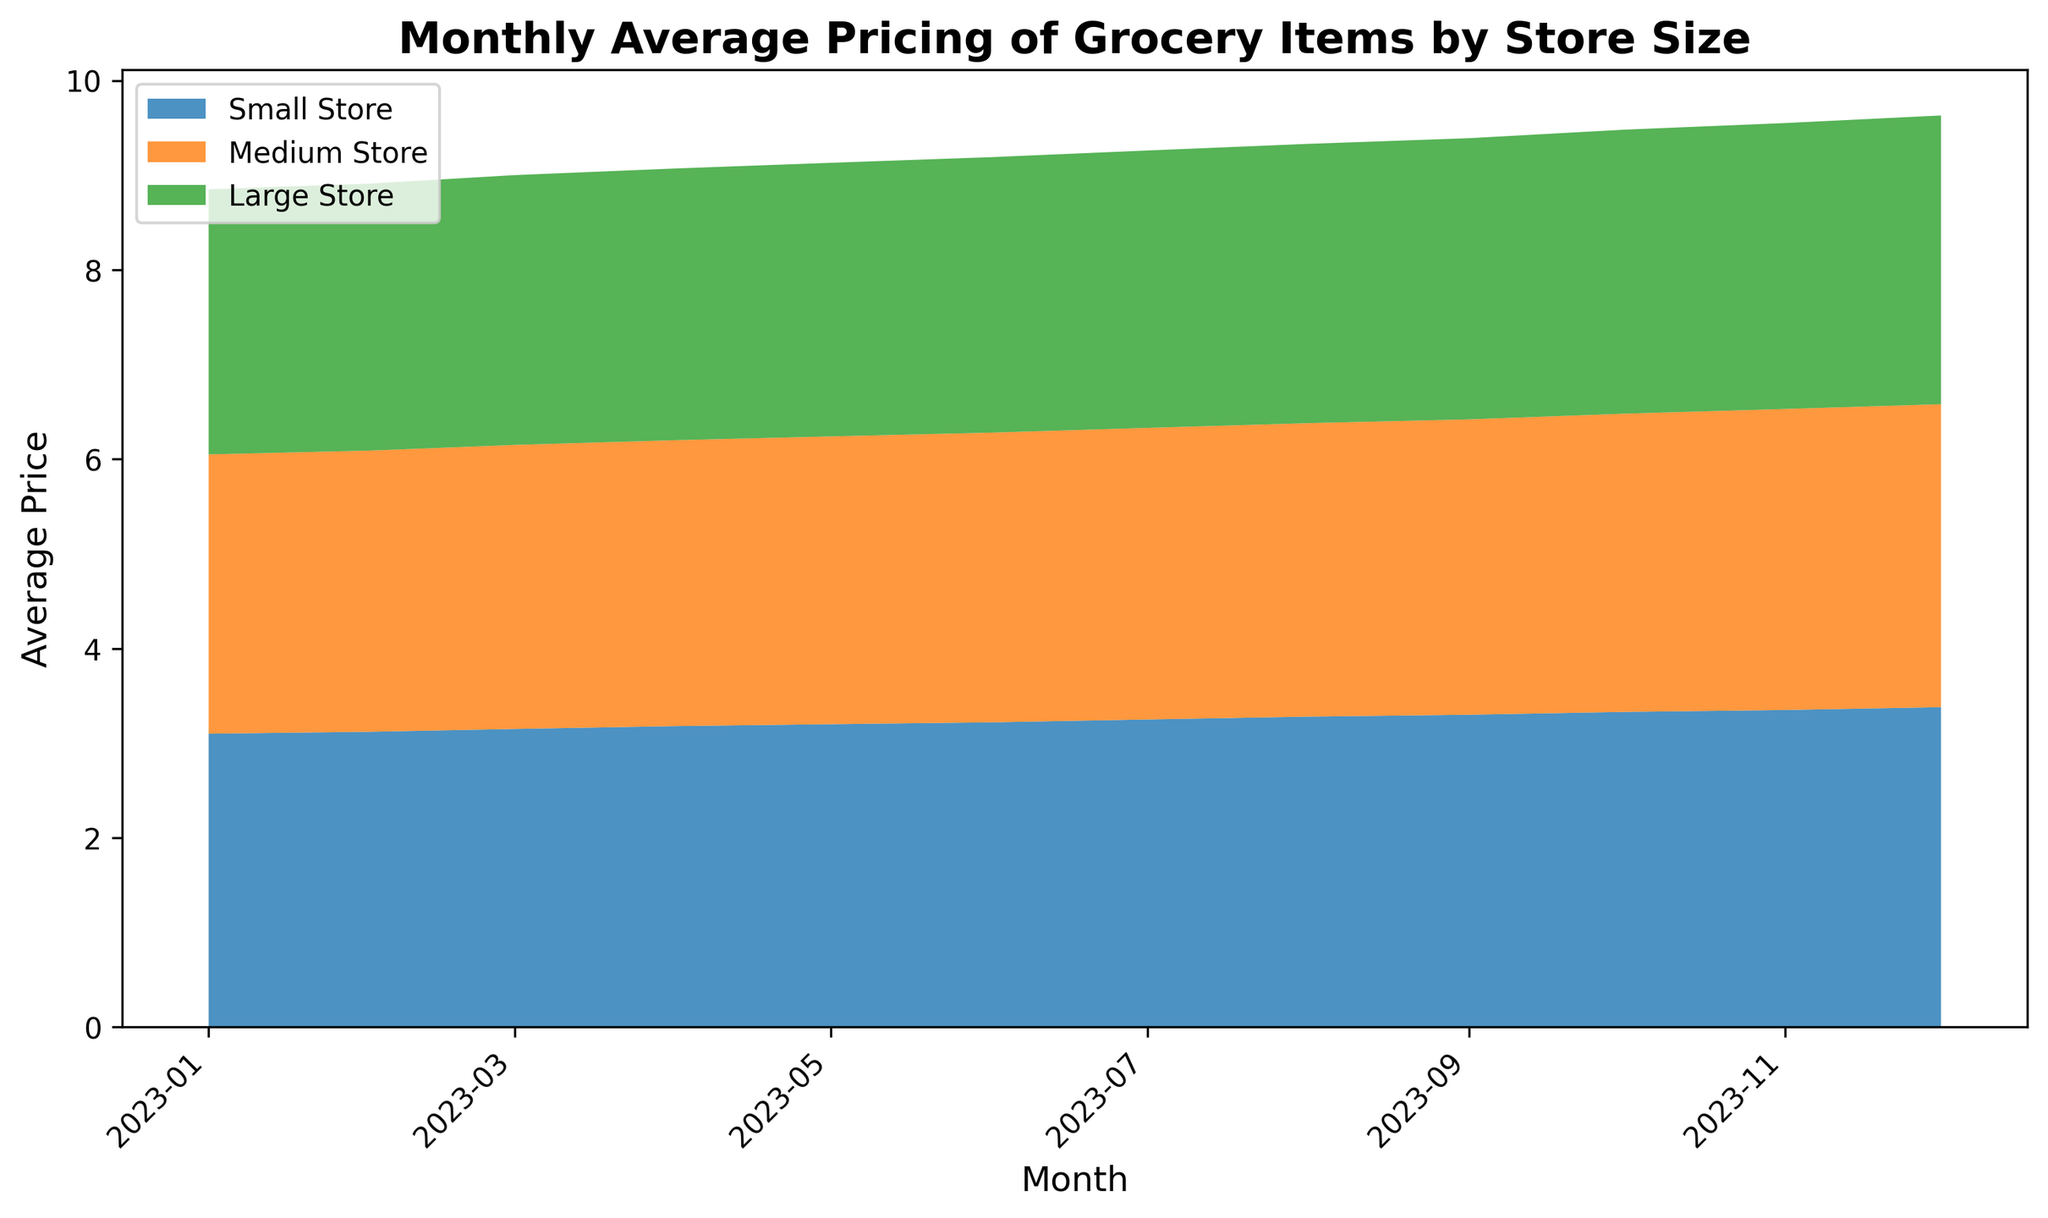what is the Monthly average pricing trend for small stores in 2023? The average prices in small stores started at $3.10 in January 2023 and increased consistently each month, ending at $3.38 in December 2023.
Answer: Increasing trend Which store size had the lowest average price in December 2023? In December 2023, the average price for small stores was $3.38, medium stores was $3.20, and large stores was $3.05. The lowest price was observed at large stores.
Answer: Large stores How does the average price in medium stores in April 2023 compare to that in June 2023? The average price in medium stores in April 2023 was $3.02, and in June 2023 it was $3.06. Thus, the price in June 2023 is higher than in April 2023.
Answer: Higher in June What is the difference in average price between small and large stores in October 2023? The average price in October 2023 for small stores was $3.33, and for large stores was $3.00. The difference is $3.33 - $3.00 = $0.33.
Answer: $0.33 Which store size shows the most significant price increase from January to December 2023? The average price in small stores increased from $3.10 in January to $3.38 in December, a change of $0.28. In medium stores, it increased from $2.95 to $3.20, a change of $0.25. For large stores, it went from $2.80 to $3.05, a change of $0.25. Thus, the small store shows the most significant increase.
Answer: Small stores What pattern can be observed in the prices of medium stores from March 2023 to July 2023? The average price in medium stores consistently increased from $3.00 in March 2023 to $3.08 in July 2023, indicating a steady growth pattern.
Answer: Consistent increase At which month do the prices of all store sizes converge closely together? The prices of all store sizes are closest in October 2023, where small stores are at $3.33, medium stores at $3.15, and large stores at $3.00.
Answer: October 2023 How much did the prices of large stores change from July to December 2023? The average price for large stores was $2.93 in July 2023 and $3.05 in December 2023. The change is $3.05 - $2.93 = $0.12.
Answer: $0.12 What is the average price in medium stores throughout 2023? Summing the monthly averages for medium stores: 2.95 + 2.97 + 3.00 + 3.02 + 3.04 + 3.06 + 3.08 + 3.10 + 3.12 + 3.15 + 3.18 + 3.20 = 36.87. Dividing by 12 months gives an average of 36.87 / 12 = 3.0725.
Answer: $3.0725 